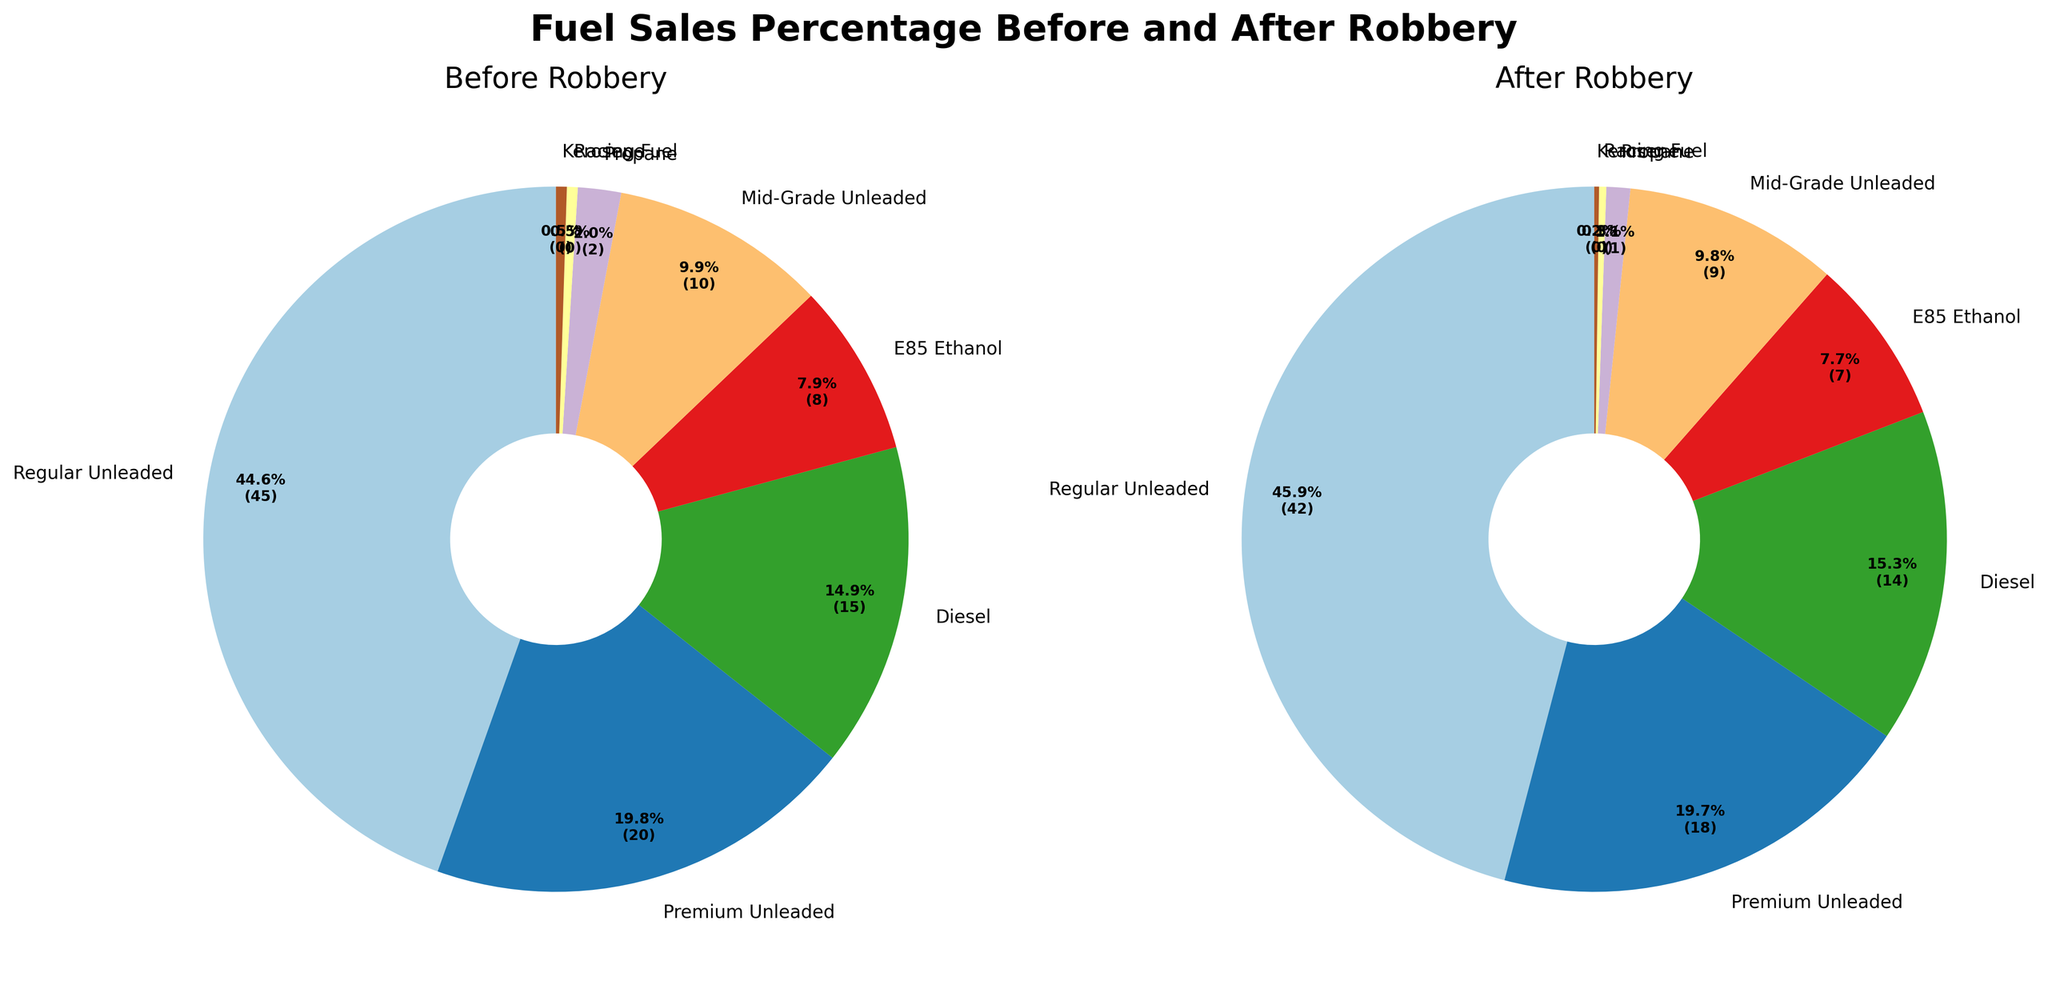What's the difference in the percentage of Regular Unleaded fuel sales before and after the robbery? To find the difference, subtract the percentage of Regular Unleaded fuel sales after the robbery from the percentage before the robbery: 45% - 42% = 3%.
Answer: 3% Which fuel type saw the greatest decrease in sales percentage after the robbery? By comparing the data, Racing Fuel decreased from 0.5% to 0.3%, a decrease of 0.2%. Kerosene decreased from 0.5% to 0.2%, a decrease of 0.3%. Comparing all, Kerosene experienced the largest decrease.
Answer: Kerosene What is the total percentage of fuel sales for Diesel and E85 Ethanol before and after the robbery? Before the robbery, sum the percentages for Diesel and E85 Ethanol: 15% + 8% = 23%. After the robbery, 14% + 7% = 21%.
Answer: Before: 23%, After: 21% Which fuel type maintained the same proportion of sales percentage when comparing before and after the robbery? Reviewing the percentages, none of the fuel types maintained the same percentage before and after the robbery. Each type saw at least a slight decrease.
Answer: None What was the percentage drop in sales for Premium Unleaded fuel due to the robbery? Subtract the after percentage from the before percentage for Premium Unleaded fuel: 20% - 18% = 2%.
Answer: 2% What is the ratio of Regular Unleaded sales to Kerosene sales before the robbery? Divide the percentages of Regular Unleaded by Kerosene before the robbery: 45% / 0.5% = 90.
Answer: 90:1 Which two fuel types had the smallest market share both before and after the robbery? By examining the smallest percentages in both datasets, Racing Fuel (0.5%, 0.3%) and Kerosene (0.5%, 0.2%) had the smallest market shares.
Answer: Racing Fuel and Kerosene If 10000 units of fuel were sold before the robbery, how many units of Mid-Grade Unleaded were sold? 10% of 10000 units is found by multiplying 10000 by 0.1: 10000 * 0.1 = 1000 units.
Answer: 1000 units How many different fuel types are represented in the chart? Count the distinct fuel types displayed in both pie charts: There are 8 different fuel types.
Answer: 8 Did the sale of Propane change significantly after the robbery? Check the Propane percentages: Before the robbery, it was 2%. After the robbery, it was 1%. The change is a decrease of 1 percentage point.
Answer: No, decreased by 1% 